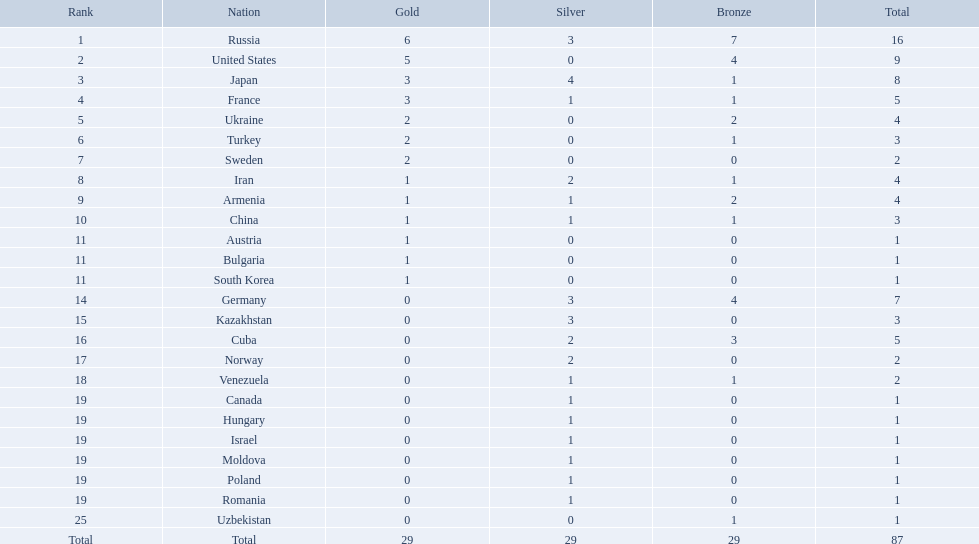Which nations are there? Russia, 6, United States, 5, Japan, 3, France, 3, Ukraine, 2, Turkey, 2, Sweden, 2, Iran, 1, Armenia, 1, China, 1, Austria, 1, Bulgaria, 1, South Korea, 1, Germany, 0, Kazakhstan, 0, Cuba, 0, Norway, 0, Venezuela, 0, Canada, 0, Hungary, 0, Israel, 0, Moldova, 0, Poland, 0, Romania, 0, Uzbekistan, 0. Which nations won gold? Russia, 6, United States, 5, Japan, 3, France, 3, Ukraine, 2, Turkey, 2, Sweden, 2, Iran, 1, Armenia, 1, China, 1, Austria, 1, Bulgaria, 1, South Korea, 1. How many golds did united states win? United States, 5. Which country has more than 5 gold medals? Russia, 6. What country is it? Russia. What nations have one gold medal? Iran, Armenia, China, Austria, Bulgaria, South Korea. Of these, which nations have zero silver medals? Austria, Bulgaria, South Korea. Of these, which nations also have zero bronze medals? Austria. Which countries were involved in the 1995 world wrestling championships? Russia, United States, Japan, France, Ukraine, Turkey, Sweden, Iran, Armenia, China, Austria, Bulgaria, South Korea, Germany, Kazakhstan, Cuba, Norway, Venezuela, Canada, Hungary, Israel, Moldova, Poland, Romania, Uzbekistan. Which country claimed merely one medal? Austria, Bulgaria, South Korea, Canada, Hungary, Israel, Moldova, Poland, Romania, Uzbekistan. Out of these, which secured a bronze medal? Uzbekistan. Which countries took part in the championships? Russia, United States, Japan, France, Ukraine, Turkey, Sweden, Iran, Armenia, China, Austria, Bulgaria, South Korea, Germany, Kazakhstan, Cuba, Norway, Venezuela, Canada, Hungary, Israel, Moldova, Poland, Romania, Uzbekistan. How many bronze medals were obtained? 7, 4, 1, 1, 2, 1, 0, 1, 2, 1, 0, 0, 0, 4, 0, 3, 0, 1, 0, 0, 0, 0, 0, 0, 1, 29. What is the total number? 16, 9, 8, 5, 4, 3, 2, 4, 4, 3, 1, 1, 1, 7, 3, 5, 2, 2, 1, 1, 1, 1, 1, 1, 1. And which team secured only one medal - the bronze? Uzbekistan. What number of countries took part? Israel. What is the sum of medals russia achieved? 16. What nation was victorious in just 1 medal? Uzbekistan. Which states were involved in the 1995 world wrestling championships? Russia, United States, Japan, France, Ukraine, Turkey, Sweden, Iran, Armenia, China, Austria, Bulgaria, South Korea, Germany, Kazakhstan, Cuba, Norway, Venezuela, Canada, Hungary, Israel, Moldova, Poland, Romania, Uzbekistan. And between iran and germany, which one was in the top 10? Germany. What was the ranking of iran? 8. What was the ranking of germany? 14. Between iran and germany, which country wasn't in the top 10? Germany. What countries exist? Russia, 6, United States, 5, Japan, 3, France, 3, Ukraine, 2, Turkey, 2, Sweden, 2, Iran, 1, Armenia, 1, China, 1, Austria, 1, Bulgaria, 1, South Korea, 1, Germany, 0, Kazakhstan, 0, Cuba, 0, Norway, 0, Venezuela, 0, Canada, 0, Hungary, 0, Israel, 0, Moldova, 0, Poland, 0, Romania, 0, Uzbekistan, 0. What countries secured gold? Russia, 6, United States, 5, Japan, 3, France, 3, Ukraine, 2, Turkey, 2, Sweden, 2, Iran, 1, Armenia, 1, China, 1, Austria, 1, Bulgaria, 1, South Korea, 1. How many golds did the united states achieve? United States, 5. Which nation has over 5 gold medals? Russia, 6. What nation is that? Russia. Which nation-states garnered less than 5 medals? Ukraine, Turkey, Sweden, Iran, Armenia, China, Austria, Bulgaria, South Korea, Germany, Kazakhstan, Norway, Venezuela, Canada, Hungary, Israel, Moldova, Poland, Romania, Uzbekistan. Which of these were not asiatic countries? Ukraine, Turkey, Sweden, Iran, Armenia, Austria, Bulgaria, Germany, Kazakhstan, Norway, Venezuela, Canada, Hungary, Israel, Moldova, Poland, Romania, Uzbekistan. Which of those did not win any silver awards? Ukraine, Turkey, Sweden, Austria, Bulgaria, Uzbekistan. Which ones of these had only a single medal altogether? Austria, Bulgaria, Uzbekistan. Which of those would be sorted first alphabetically? Austria. What was iran's position? 8. What was germany's position? 14. Between iran and germany, which one was not among the top 10? Germany. What was iran's position in the ranking? 8. What was germany's position in the ranking? 14. Which one of them was in the top 10 rankings? Germany. In the 1995 world wrestling championships, which countries took part? Russia, United States, Japan, France, Ukraine, Turkey, Sweden, Iran, Armenia, China, Austria, Bulgaria, South Korea, Germany, Kazakhstan, Cuba, Norway, Venezuela, Canada, Hungary, Israel, Moldova, Poland, Romania, Uzbekistan. Additionally, did either iran or germany rank among the top 10? Germany. What was the position of iran? 8. What was the position of germany? 14. Which one of iran and germany did not make it to the top 10? Germany. What is the total number of gold medals won by the united states? 5. Which individuals have won over 5 gold medals? Russia. How many gold medals has the united states achieved? 5. Can you name those who have secured more than 5 gold medals? Russia. What is the count of gold medals the united states has won? 5. Who are the athletes with more than 5 gold medals to their name? Russia. In the 1995 world wrestling championships, which nations participated? Russia, United States, Japan, France, Ukraine, Turkey, Sweden, Iran, Armenia, China, Austria, Bulgaria, South Korea, Germany, Kazakhstan, Cuba, Norway, Venezuela, Canada, Hungary, Israel, Moldova, Poland, Romania, Uzbekistan. Which country secured just a single medal? Austria, Bulgaria, South Korea, Canada, Hungary, Israel, Moldova, Poland, Romania, Uzbekistan. Among these, who achieved a bronze medal? Uzbekistan. Which nations took part in the 1995 world wrestling championships? Russia, United States, Japan, France, Ukraine, Turkey, Sweden, Iran, Armenia, China, Austria, Bulgaria, South Korea, Germany, Kazakhstan, Cuba, Norway, Venezuela, Canada, Hungary, Israel, Moldova, Poland, Romania, Uzbekistan. Which one of them earned only one medal? Austria, Bulgaria, South Korea, Canada, Hungary, Israel, Moldova, Poland, Romania, Uzbekistan. Who among them received a bronze medal? Uzbekistan. What was the number of participating nations? Israel. How many medals were won by russia in total? 16. Which nation secured only a single medal? Uzbekistan. In which countries can you find only one gold medal? Iran, Armenia, China, Austria, Bulgaria, South Korea. Out of those, which ones don't have any silver medals? Austria, Bulgaria, South Korea. Additionally, which of these countries lack bronze medals too? Austria. Which countries secured less than 5 medals? Ukraine, Turkey, Sweden, Iran, Armenia, China, Austria, Bulgaria, South Korea, Germany, Kazakhstan, Norway, Venezuela, Canada, Hungary, Israel, Moldova, Poland, Romania, Uzbekistan. Among them, which are not from asia? Ukraine, Turkey, Sweden, Iran, Armenia, Austria, Bulgaria, Germany, Kazakhstan, Norway, Venezuela, Canada, Hungary, Israel, Moldova, Poland, Romania, Uzbekistan. From this subset, which did not receive any silver medals? Ukraine, Turkey, Sweden, Austria, Bulgaria, Uzbekistan. From this group, which had only a single medal? Austria, Bulgaria, Uzbekistan. Lastly, which one comes first in alphabetical order? Austria. Could you parse the entire table? {'header': ['Rank', 'Nation', 'Gold', 'Silver', 'Bronze', 'Total'], 'rows': [['1', 'Russia', '6', '3', '7', '16'], ['2', 'United States', '5', '0', '4', '9'], ['3', 'Japan', '3', '4', '1', '8'], ['4', 'France', '3', '1', '1', '5'], ['5', 'Ukraine', '2', '0', '2', '4'], ['6', 'Turkey', '2', '0', '1', '3'], ['7', 'Sweden', '2', '0', '0', '2'], ['8', 'Iran', '1', '2', '1', '4'], ['9', 'Armenia', '1', '1', '2', '4'], ['10', 'China', '1', '1', '1', '3'], ['11', 'Austria', '1', '0', '0', '1'], ['11', 'Bulgaria', '1', '0', '0', '1'], ['11', 'South Korea', '1', '0', '0', '1'], ['14', 'Germany', '0', '3', '4', '7'], ['15', 'Kazakhstan', '0', '3', '0', '3'], ['16', 'Cuba', '0', '2', '3', '5'], ['17', 'Norway', '0', '2', '0', '2'], ['18', 'Venezuela', '0', '1', '1', '2'], ['19', 'Canada', '0', '1', '0', '1'], ['19', 'Hungary', '0', '1', '0', '1'], ['19', 'Israel', '0', '1', '0', '1'], ['19', 'Moldova', '0', '1', '0', '1'], ['19', 'Poland', '0', '1', '0', '1'], ['19', 'Romania', '0', '1', '0', '1'], ['25', 'Uzbekistan', '0', '0', '1', '1'], ['Total', 'Total', '29', '29', '29', '87']]} In which countries did the total medal count not exceed 4? Ukraine, Turkey, Sweden, Iran, Armenia, China, Austria, Bulgaria, South Korea, Germany, Kazakhstan, Norway, Venezuela, Canada, Hungary, Israel, Moldova, Poland, Romania, Uzbekistan. Which of these are not located in asia? Ukraine, Turkey, Sweden, Iran, Armenia, Austria, Bulgaria, Germany, Kazakhstan, Norway, Venezuela, Canada, Hungary, Israel, Moldova, Poland, Romania, Uzbekistan. From this list, which ones did not earn any silver medals? Ukraine, Turkey, Sweden, Austria, Bulgaria, Uzbekistan. Among these, which had just one medal? Austria, Bulgaria, Uzbekistan. Finally, which of them appears first alphabetically? Austria. 